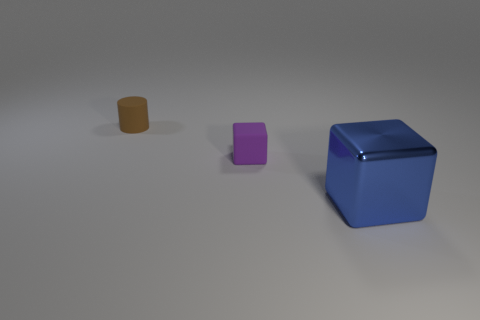Are there any metallic blocks that are in front of the tiny matte thing that is in front of the tiny object that is behind the small purple cube?
Your answer should be compact. Yes. Are there any large blue things to the right of the big metallic thing?
Ensure brevity in your answer.  No. Are there any tiny metal cubes of the same color as the big shiny cube?
Your response must be concise. No. What number of big things are blue things or brown objects?
Provide a succinct answer. 1. Are the cube that is on the left side of the blue thing and the large block made of the same material?
Your answer should be very brief. No. What shape is the small matte thing that is in front of the tiny thing behind the small object that is on the right side of the brown rubber thing?
Your answer should be very brief. Cube. How many cyan things are either big matte cylinders or metal things?
Your answer should be very brief. 0. Are there an equal number of small matte objects that are in front of the small brown thing and brown matte things on the right side of the tiny purple cube?
Your answer should be compact. No. There is a tiny object that is behind the small purple block; is its shape the same as the small matte object to the right of the tiny brown object?
Your answer should be very brief. No. Is there any other thing that is the same shape as the big blue shiny thing?
Provide a short and direct response. Yes. 